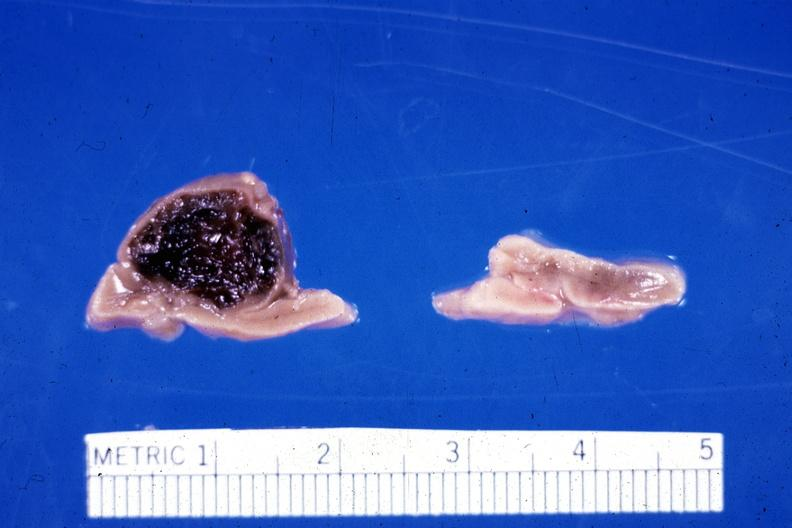s marfans syndrome present?
Answer the question using a single word or phrase. No 